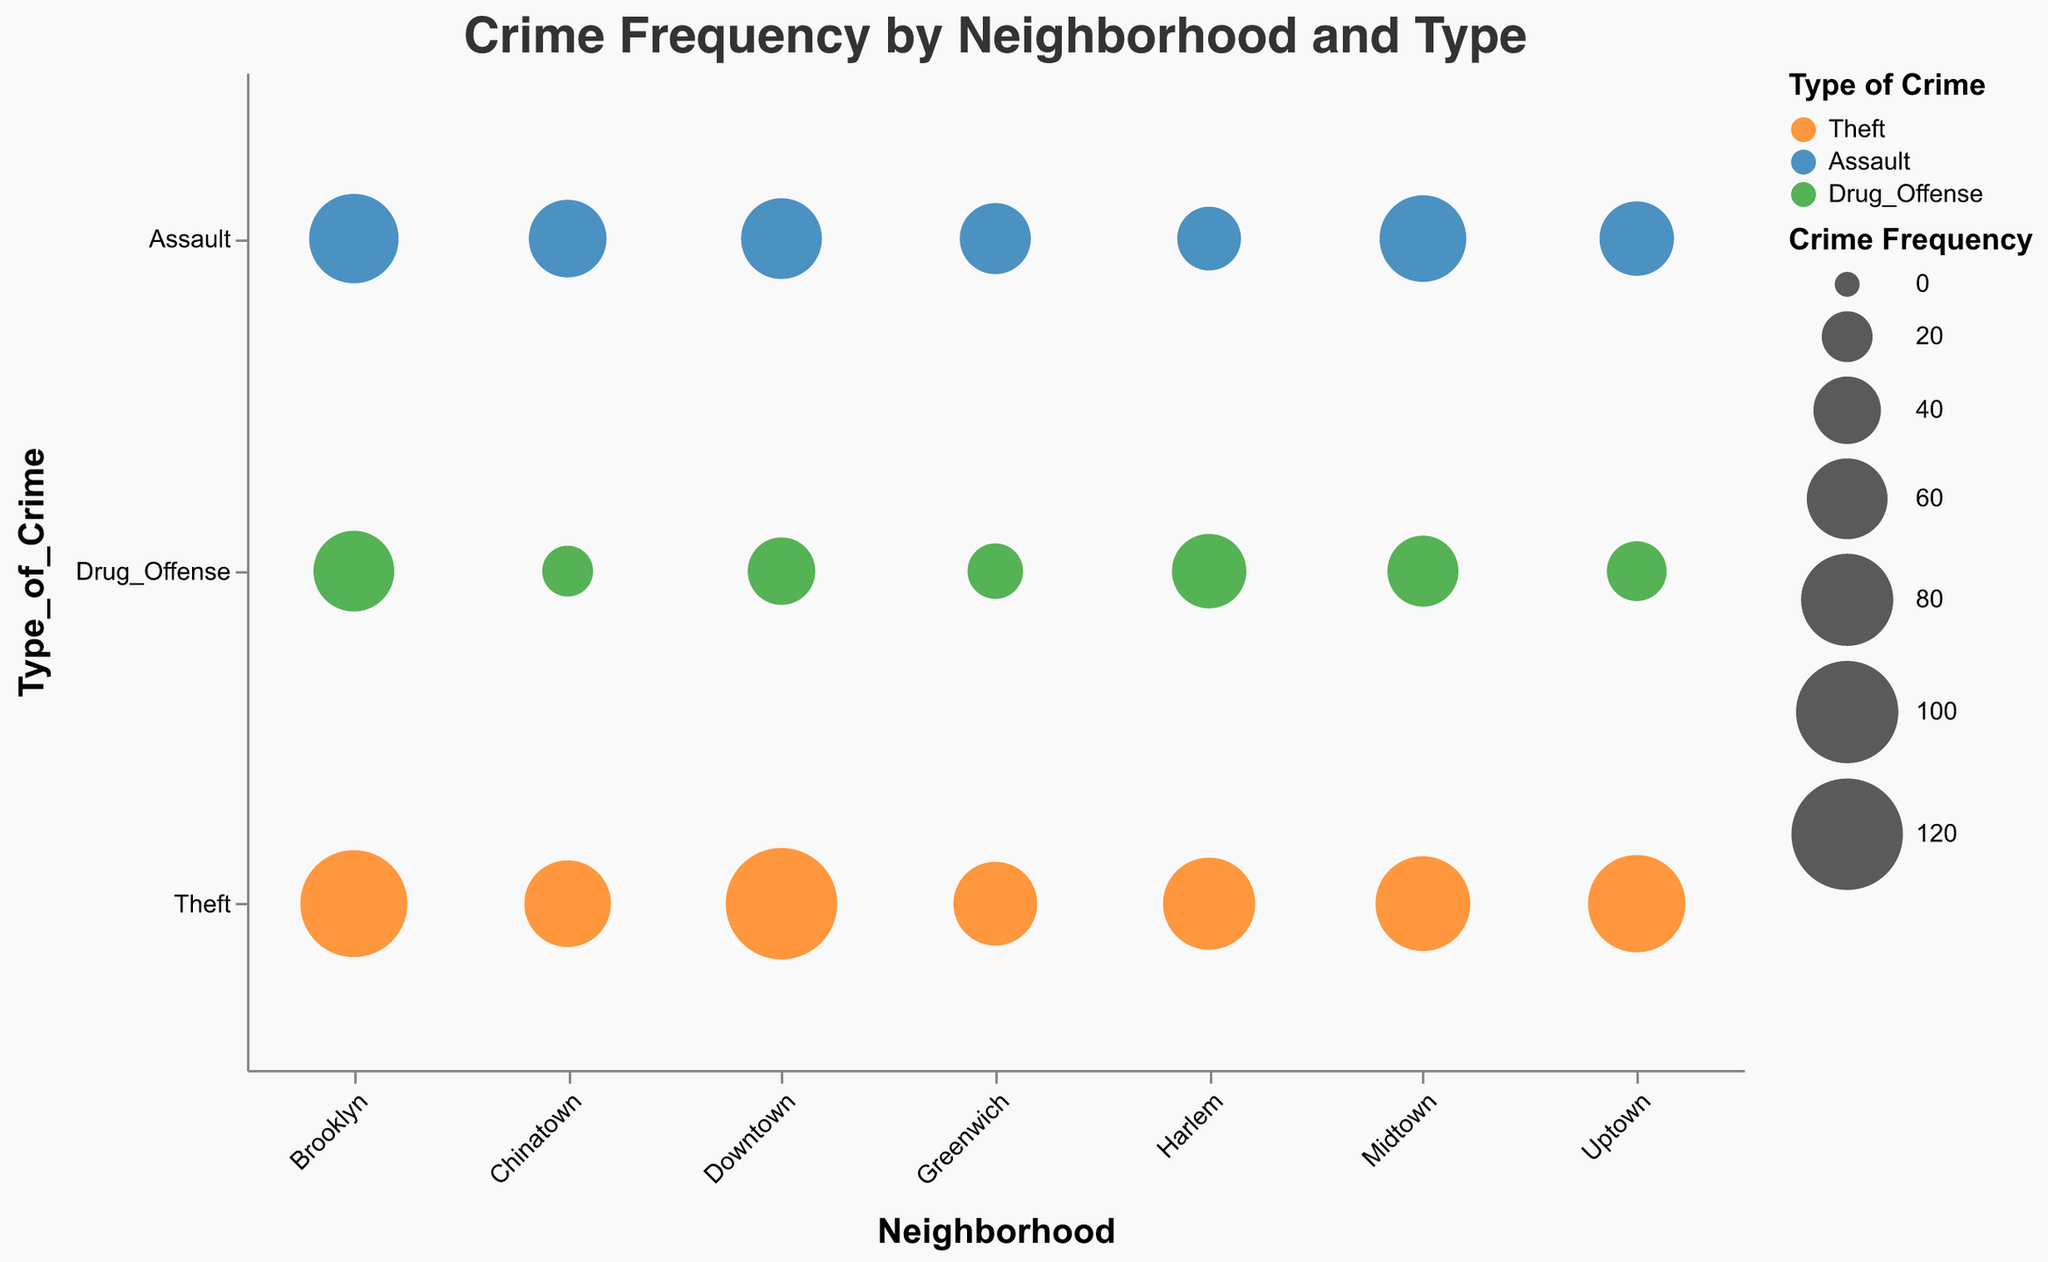What is the title of the chart? The title can be found at the top of the chart. It states, "Crime Frequency by Neighborhood and Type".
Answer: Crime Frequency by Neighborhood and Type Which neighborhood has the highest frequency of theft? Look for the largest bubble in the row corresponding to "Theft". The largest bubble under "Theft" is located in the "Downtown" column with a frequency of 120.
Answer: Downtown Which type of crime has the highest frequency in Brooklyn? Identify the largest bubble in the "Brooklyn" column. For Brooklyn, the biggest bubble has a frequency of 110, corresponding to the "Theft" category.
Answer: Theft What is the total frequency of assaults across all neighborhoods? Add up the frequencies of assaults across all neighborhoods (60 for Downtown, 50 for Uptown, 70 for Midtown, 55 for Chinatown, 45 for Greenwich, 35 for Harlem, 75 for Brooklyn). 60 + 50 + 70 + 55 + 45 + 35 + 75 = 390.
Answer: 390 Which neighborhood has the lowest frequency of Drug_Offense? Look for the smallest bubble in the row labeled "Drug_Offense". The smallest frequency for Drug_Offense is 20, which is in the "Chinatown" column.
Answer: Chinatown Compare the frequency of Theft in Uptown and Downtown. Which neighborhood has a higher frequency? Look at the size of the bubbles in the "Theft" row for both Uptown and Downtown. Uptown has a frequency of 90, while Downtown has a frequency of 120. Downtown has a higher frequency.
Answer: Downtown What is the average frequency of crime types in Midtown? Calculate the average by adding the frequencies of all crime types in Midtown and dividing by the number of types (85 for Theft, 70 for Assault, 45 for Drug_Offense). (85 + 70 + 45) / 3 = 66.67.
Answer: 66.67 For the "Assault" crime type, which neighborhood has the median frequency? List the assault frequencies across neighborhoods (35 for Harlem, 45 for Greenwich, 50 for Uptown, 55 for Chinatown, 60 for Downtown, 70 for Midtown, 75 for Brooklyn). The median value is 55.
Answer: Chinatown How many neighborhoods have a frequency of Drug_Offense greater than 40? Compare the frequency of Drug_Offense for each neighborhood and count those greater than 40 (Downtown, Midtown, Harlem, Brooklyn). There are 4 neighborhoods.
Answer: 4 What can you say about the color representation in the chart? The colors correspond to different types of crimes. Theft is orange, Assault is blue, and Drug_Offense is green.
Answer: Orange, Blue, Green 